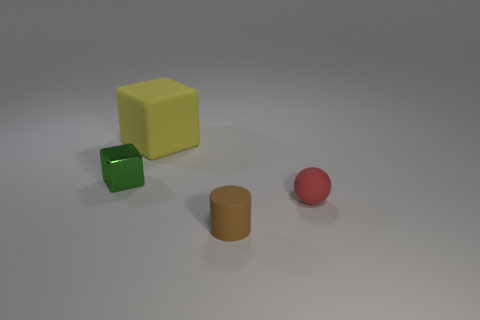Subtract all green blocks. How many blocks are left? 1 Subtract 1 cylinders. How many cylinders are left? 0 Add 3 big cyan metal objects. How many objects exist? 7 Subtract 1 red balls. How many objects are left? 3 Subtract all purple balls. Subtract all yellow blocks. How many balls are left? 1 Subtract all green spheres. How many green blocks are left? 1 Subtract all tiny balls. Subtract all tiny cylinders. How many objects are left? 2 Add 3 tiny matte cylinders. How many tiny matte cylinders are left? 4 Add 3 tiny objects. How many tiny objects exist? 6 